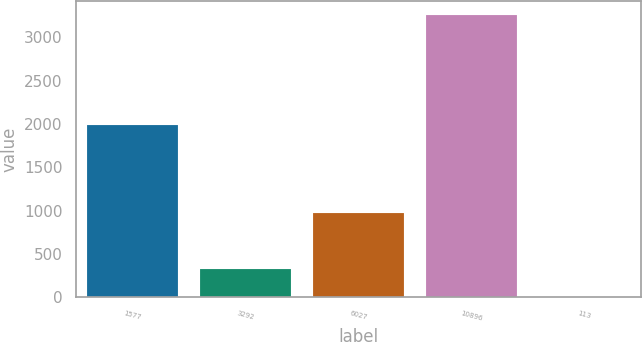Convert chart to OTSL. <chart><loc_0><loc_0><loc_500><loc_500><bar_chart><fcel>1577<fcel>3292<fcel>6027<fcel>10896<fcel>113<nl><fcel>1993<fcel>329.06<fcel>972<fcel>3260<fcel>3.4<nl></chart> 